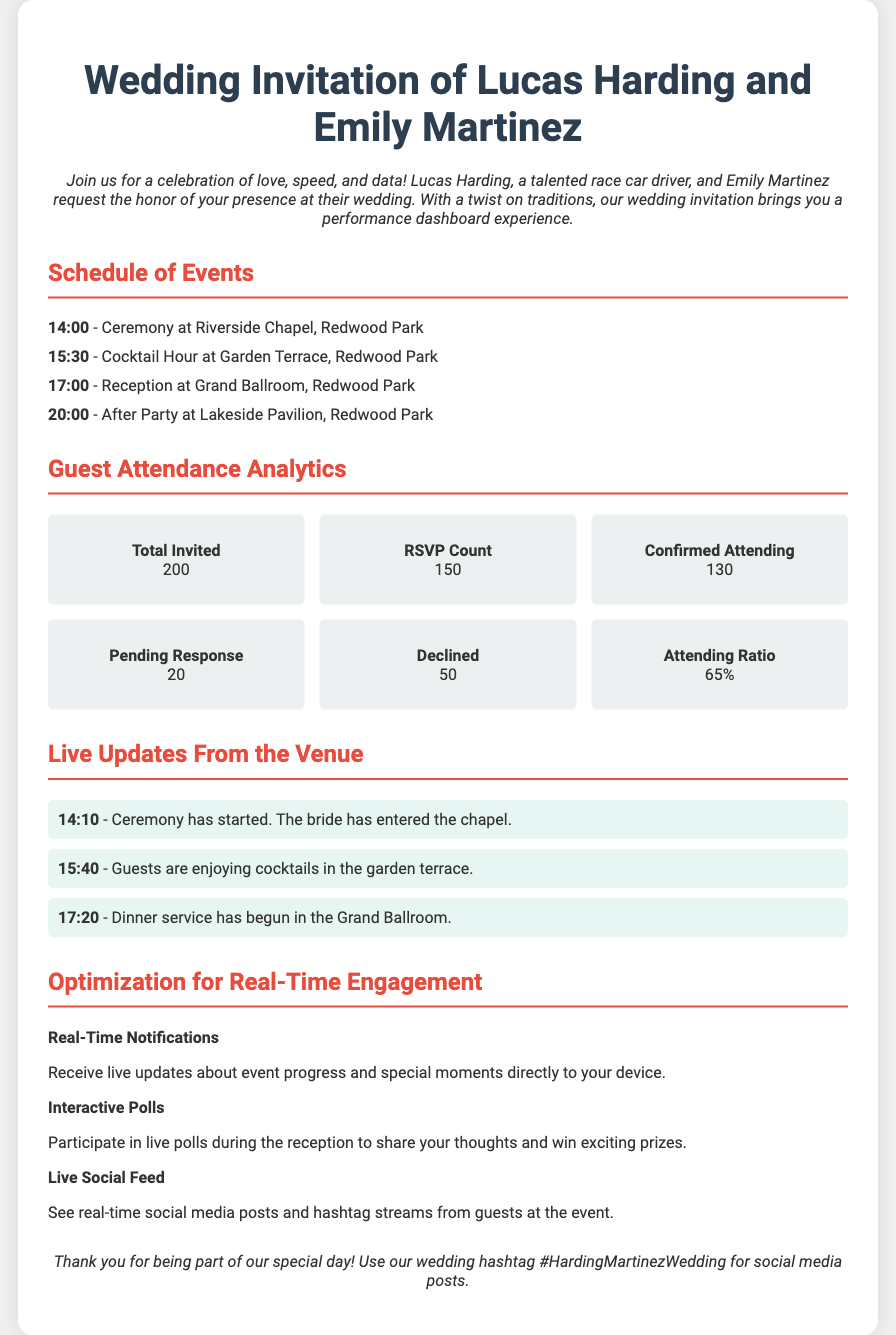What time does the ceremony start? The ceremony starts at 14:00, as explicitly stated in the schedule of events.
Answer: 14:00 How many total guests were invited? The total number of invited guests is mentioned in the attendance analytics section, which is 200.
Answer: 200 What percentage of guests confirmed their attendance? The confirmed attending ratio is provided in the analytics section as 130 out of 200, which gives an attending ratio of 65%.
Answer: 65% What event follows the cocktail hour? The reception follows the cocktail hour, as listed in the schedule of events; it starts at 17:00.
Answer: Reception What is the main feature of the wedding invitation? The main feature emphasized in the introduction is the performance dashboard experience that incorporates various analytics.
Answer: Performance dashboard experience What type of updates can guests expect during the event? Guests can expect live updates from the venue, which include real-time notifications about the event's progress.
Answer: Live updates How many guests have declined the invitation? The analytics section states that 50 guests have declined the invitation.
Answer: 50 What interactive activity is mentioned for the reception? The invitation includes the mention of interactive polls during the reception as an activity for guest engagement.
Answer: Interactive polls What is the hashtag for social media posts? The hashtag for the wedding is provided at the end of the document to encourage sharing on social media.
Answer: #HardingMartinezWedding 